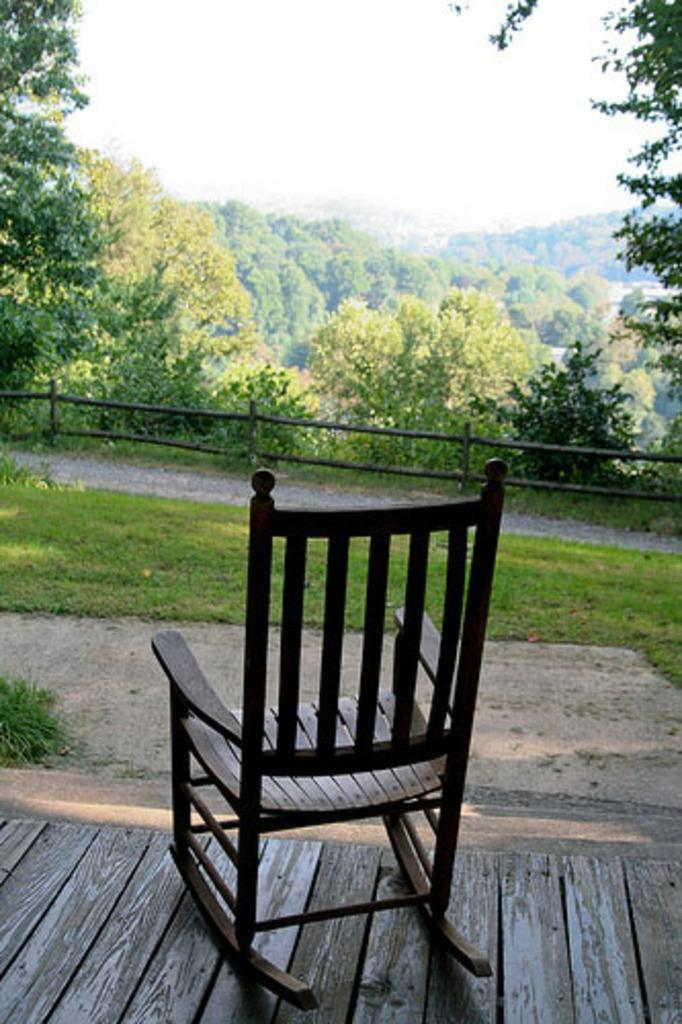What type of furniture is present in the image? There is a chair in the image. What can be seen in the background of the image? There are trees and sky visible in the background of the image. What type of barrier is present in the image? There is a fence in the image. What type of vegetation is present in the image? There is grass in the image. How many ducks are sitting on the chair in the image? There are no ducks present in the image; it only features a chair, trees, sky, a fence, and grass. 